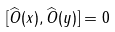Convert formula to latex. <formula><loc_0><loc_0><loc_500><loc_500>[ \widehat { O } ( x ) , \widehat { O } ( y ) ] = 0</formula> 